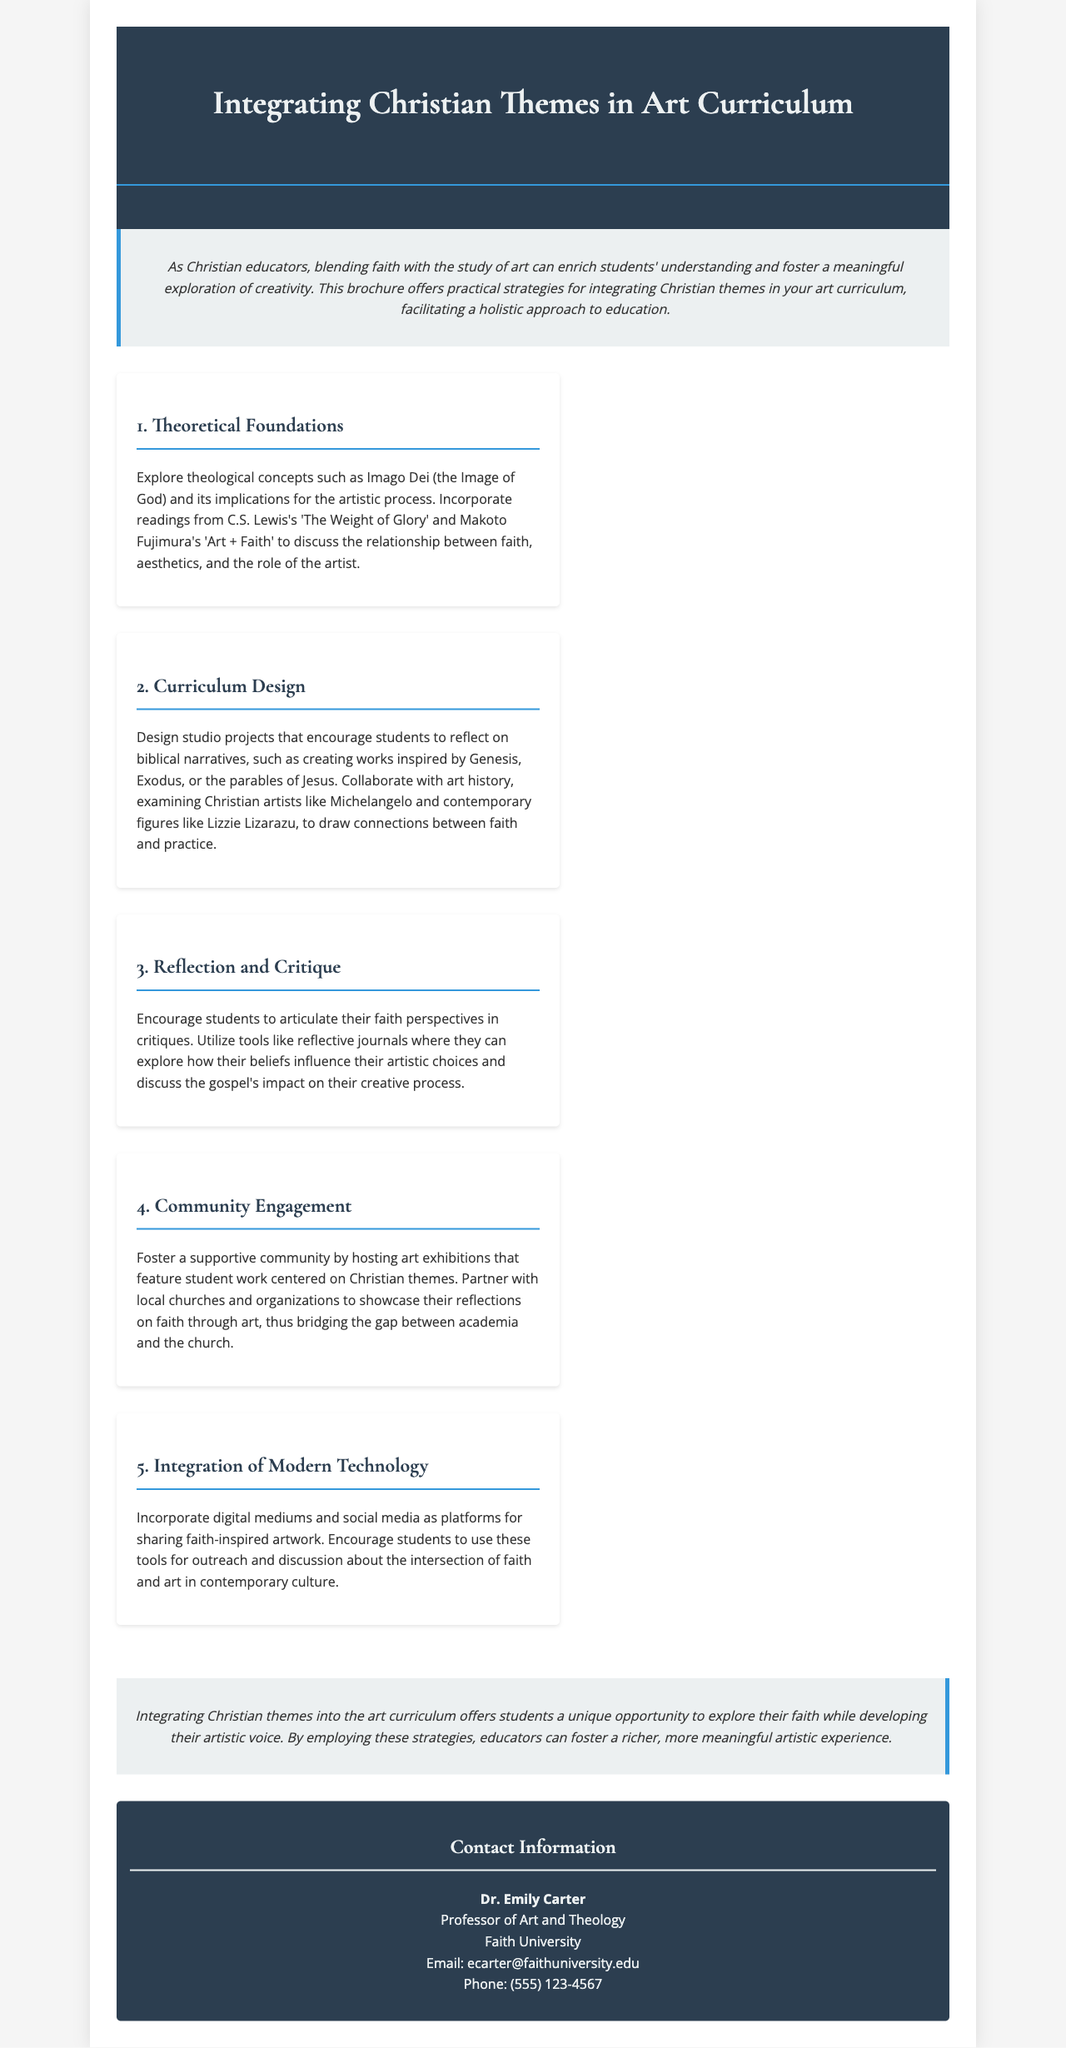What is the title of the brochure? The title of the brochure is prominently displayed at the top and is "Integrating Christian Themes in Art Curriculum."
Answer: Integrating Christian Themes in Art Curriculum Who is the author of the brochure? The contact information at the end of the document lists the author as Dr. Emily Carter.
Answer: Dr. Emily Carter What is one of the theological concepts discussed in the brochure? The document mentions Imago Dei as a theological concept in the context of art.
Answer: Imago Dei Which artist is referenced in the section on Curriculum Design? The section mentions Michelangelo as one of the Christian artists discussed.
Answer: Michelangelo What does the community engagement section suggest hosting? The community engagement section suggests hosting art exhibitions featuring student work.
Answer: Art exhibitions What is one modern technology suggested for integrating art and faith? The brochure suggests incorporating social media as a platform for sharing artwork.
Answer: Social media How many sections of practical strategies are detailed in the brochure? The document lists five distinct sections outlining practical strategies for educators.
Answer: Five What role does reflective journaling play in the curriculum? The brochure describes reflective journaling as a tool for students to explore their faith perspectives in critiques.
Answer: Explore faith perspectives What university is Dr. Emily Carter associated with? The contact information specifies that Dr. Emily Carter is associated with Faith University.
Answer: Faith University 